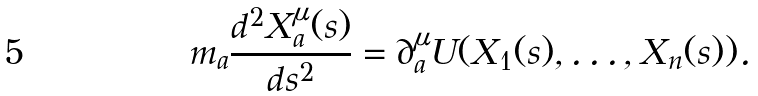<formula> <loc_0><loc_0><loc_500><loc_500>m _ { a } \frac { d ^ { 2 } X _ { a } ^ { \mu } ( s ) } { d s ^ { 2 } } = \partial _ { a } ^ { \mu } U ( X _ { 1 } ( s ) , \dots , X _ { n } ( s ) ) .</formula> 